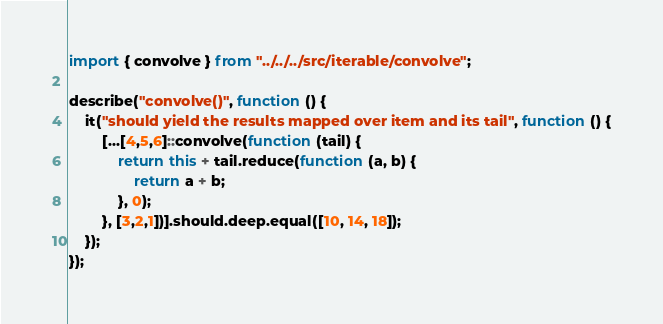<code> <loc_0><loc_0><loc_500><loc_500><_JavaScript_>import { convolve } from "../../../src/iterable/convolve";

describe("convolve()", function () {
    it("should yield the results mapped over item and its tail", function () {
        [...[4,5,6]::convolve(function (tail) {
            return this + tail.reduce(function (a, b) {
                return a + b;
            }, 0);
        }, [3,2,1])].should.deep.equal([10, 14, 18]);
    });
});
</code> 